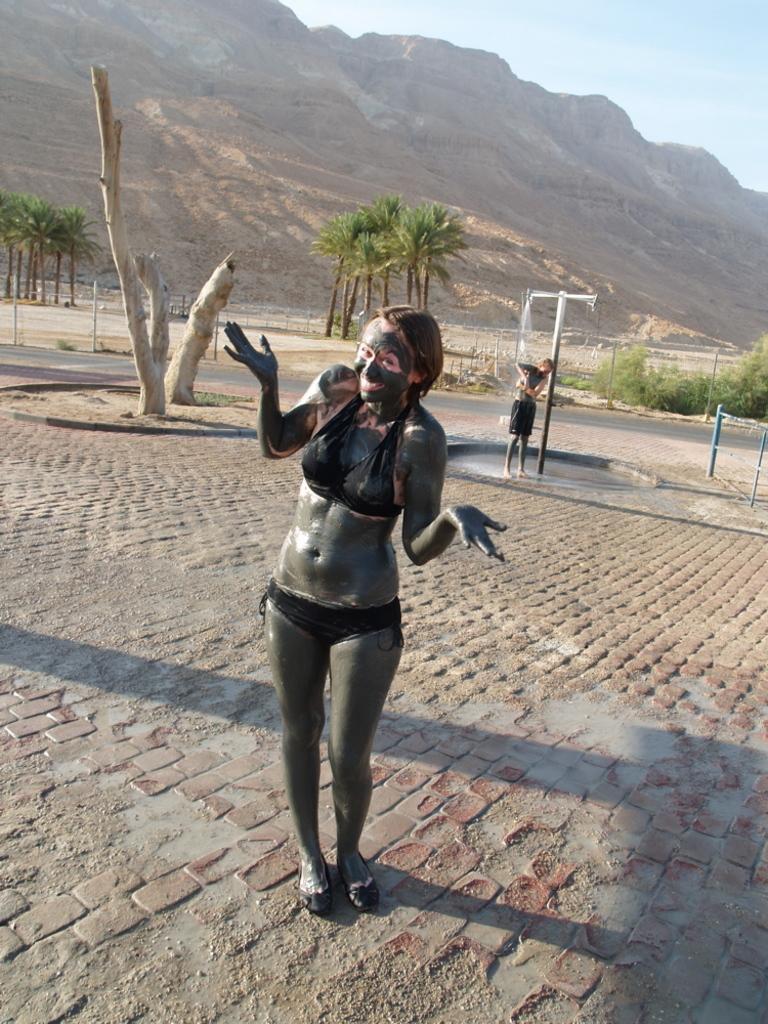Can you describe this image briefly? In this image I can see a person standing, at back I can see trees in green color and the other person standing, mountains and sky in blue color. 